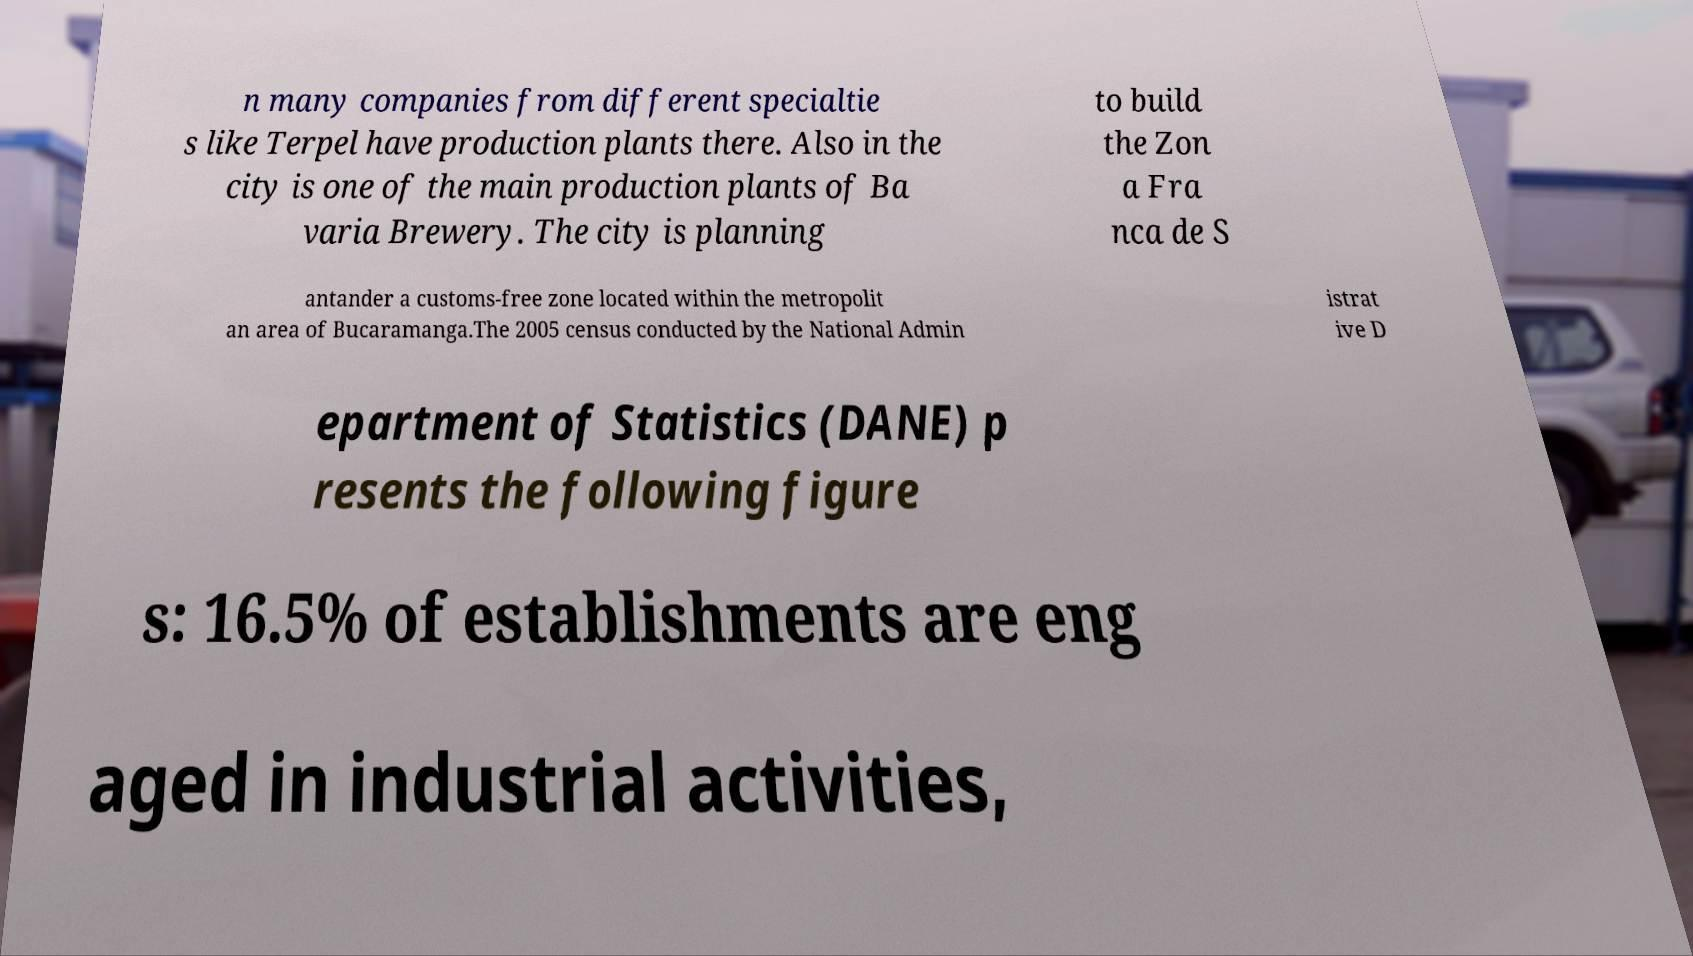I need the written content from this picture converted into text. Can you do that? n many companies from different specialtie s like Terpel have production plants there. Also in the city is one of the main production plants of Ba varia Brewery. The city is planning to build the Zon a Fra nca de S antander a customs-free zone located within the metropolit an area of Bucaramanga.The 2005 census conducted by the National Admin istrat ive D epartment of Statistics (DANE) p resents the following figure s: 16.5% of establishments are eng aged in industrial activities, 